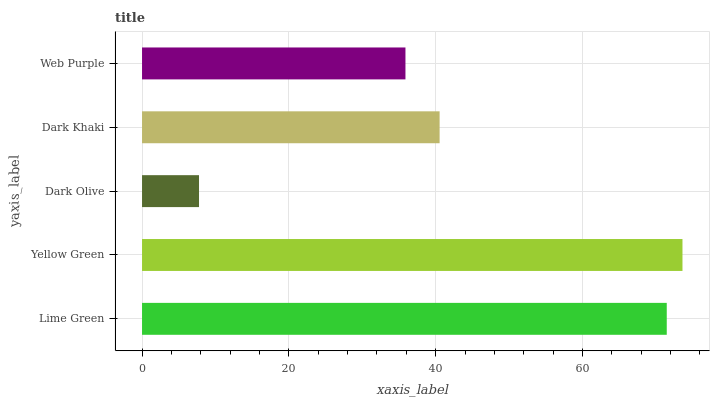Is Dark Olive the minimum?
Answer yes or no. Yes. Is Yellow Green the maximum?
Answer yes or no. Yes. Is Yellow Green the minimum?
Answer yes or no. No. Is Dark Olive the maximum?
Answer yes or no. No. Is Yellow Green greater than Dark Olive?
Answer yes or no. Yes. Is Dark Olive less than Yellow Green?
Answer yes or no. Yes. Is Dark Olive greater than Yellow Green?
Answer yes or no. No. Is Yellow Green less than Dark Olive?
Answer yes or no. No. Is Dark Khaki the high median?
Answer yes or no. Yes. Is Dark Khaki the low median?
Answer yes or no. Yes. Is Dark Olive the high median?
Answer yes or no. No. Is Yellow Green the low median?
Answer yes or no. No. 